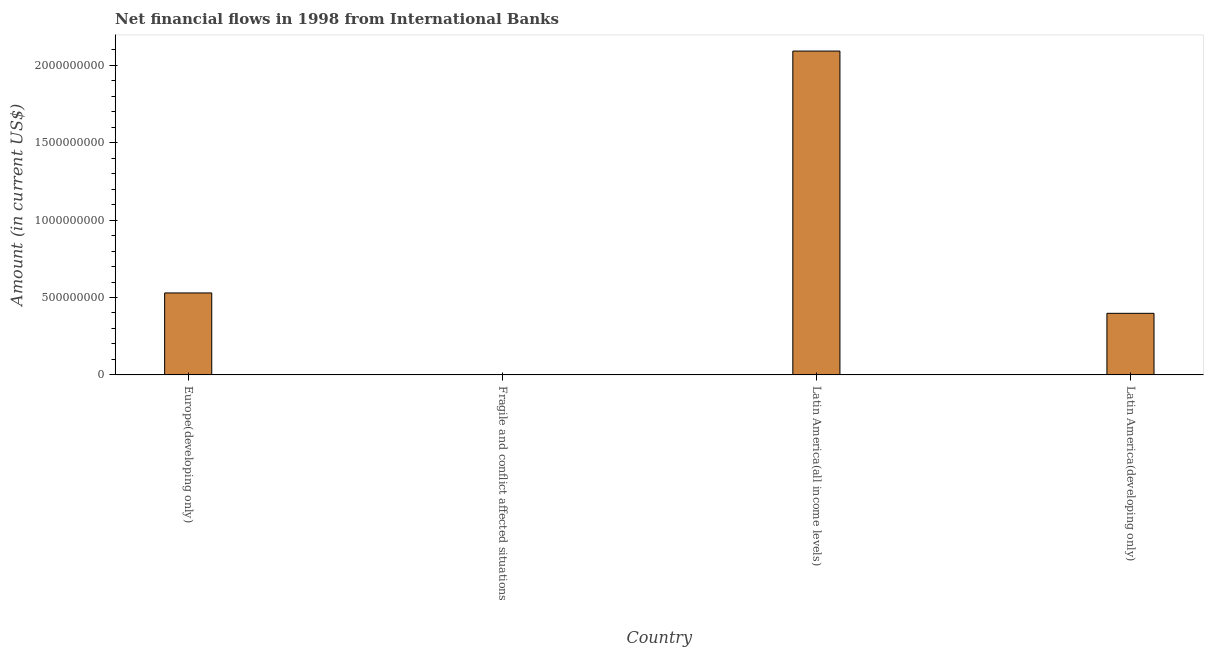Does the graph contain any zero values?
Provide a succinct answer. Yes. What is the title of the graph?
Keep it short and to the point. Net financial flows in 1998 from International Banks. What is the label or title of the X-axis?
Offer a terse response. Country. What is the label or title of the Y-axis?
Your answer should be very brief. Amount (in current US$). What is the net financial flows from ibrd in Latin America(developing only)?
Provide a short and direct response. 3.98e+08. Across all countries, what is the maximum net financial flows from ibrd?
Provide a short and direct response. 2.09e+09. Across all countries, what is the minimum net financial flows from ibrd?
Ensure brevity in your answer.  0. In which country was the net financial flows from ibrd maximum?
Your answer should be compact. Latin America(all income levels). What is the sum of the net financial flows from ibrd?
Make the answer very short. 3.02e+09. What is the difference between the net financial flows from ibrd in Europe(developing only) and Latin America(developing only)?
Provide a short and direct response. 1.32e+08. What is the average net financial flows from ibrd per country?
Provide a short and direct response. 7.55e+08. What is the median net financial flows from ibrd?
Provide a short and direct response. 4.64e+08. In how many countries, is the net financial flows from ibrd greater than 1200000000 US$?
Your answer should be compact. 1. What is the ratio of the net financial flows from ibrd in Europe(developing only) to that in Latin America(developing only)?
Ensure brevity in your answer.  1.33. What is the difference between the highest and the second highest net financial flows from ibrd?
Keep it short and to the point. 1.56e+09. Is the sum of the net financial flows from ibrd in Europe(developing only) and Latin America(developing only) greater than the maximum net financial flows from ibrd across all countries?
Keep it short and to the point. No. What is the difference between the highest and the lowest net financial flows from ibrd?
Your answer should be compact. 2.09e+09. How many bars are there?
Provide a succinct answer. 3. What is the difference between two consecutive major ticks on the Y-axis?
Give a very brief answer. 5.00e+08. Are the values on the major ticks of Y-axis written in scientific E-notation?
Your answer should be compact. No. What is the Amount (in current US$) of Europe(developing only)?
Offer a terse response. 5.29e+08. What is the Amount (in current US$) in Latin America(all income levels)?
Provide a succinct answer. 2.09e+09. What is the Amount (in current US$) in Latin America(developing only)?
Make the answer very short. 3.98e+08. What is the difference between the Amount (in current US$) in Europe(developing only) and Latin America(all income levels)?
Ensure brevity in your answer.  -1.56e+09. What is the difference between the Amount (in current US$) in Europe(developing only) and Latin America(developing only)?
Offer a very short reply. 1.32e+08. What is the difference between the Amount (in current US$) in Latin America(all income levels) and Latin America(developing only)?
Provide a short and direct response. 1.69e+09. What is the ratio of the Amount (in current US$) in Europe(developing only) to that in Latin America(all income levels)?
Offer a terse response. 0.25. What is the ratio of the Amount (in current US$) in Europe(developing only) to that in Latin America(developing only)?
Offer a terse response. 1.33. What is the ratio of the Amount (in current US$) in Latin America(all income levels) to that in Latin America(developing only)?
Ensure brevity in your answer.  5.26. 